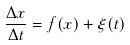Convert formula to latex. <formula><loc_0><loc_0><loc_500><loc_500>\frac { \Delta x } { \Delta t } = f ( x ) + \xi ( t )</formula> 